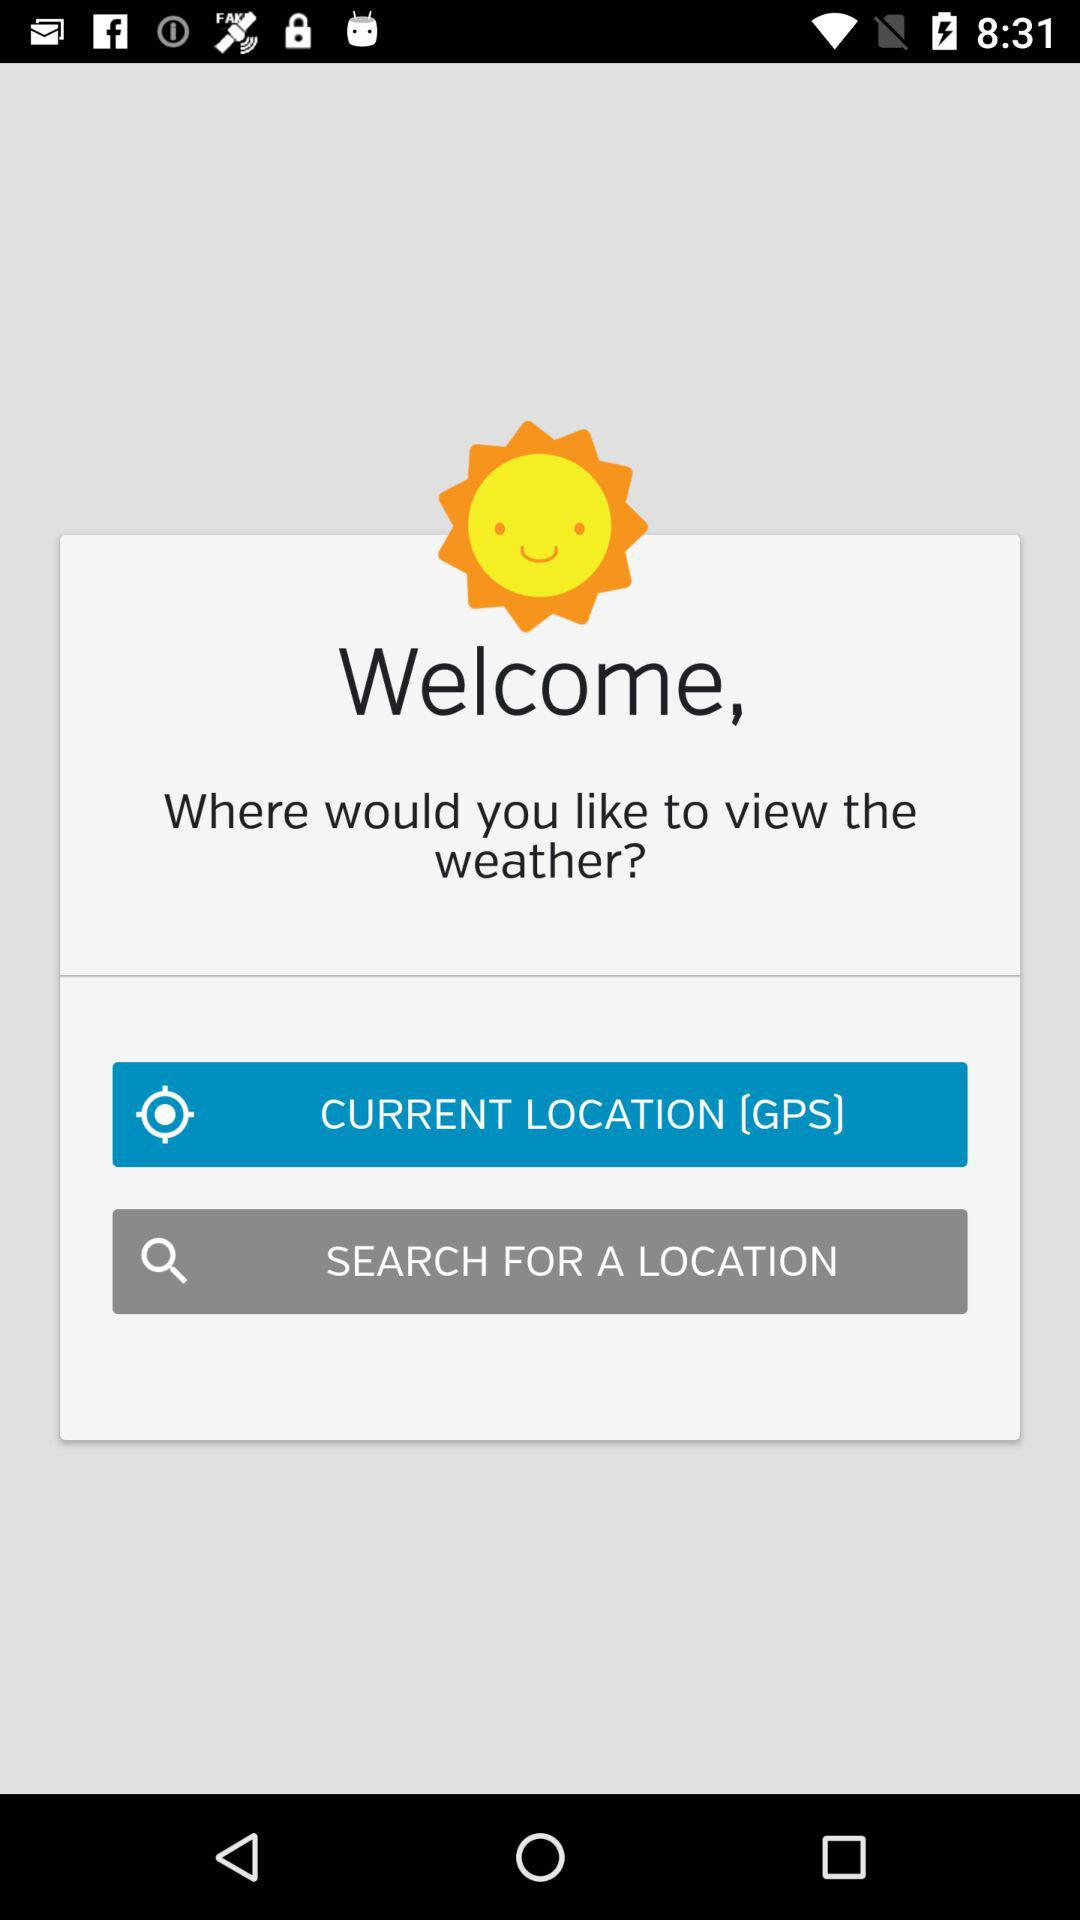Which option is selected? The selected option is "CURRENT LOCATION (GPS)". 